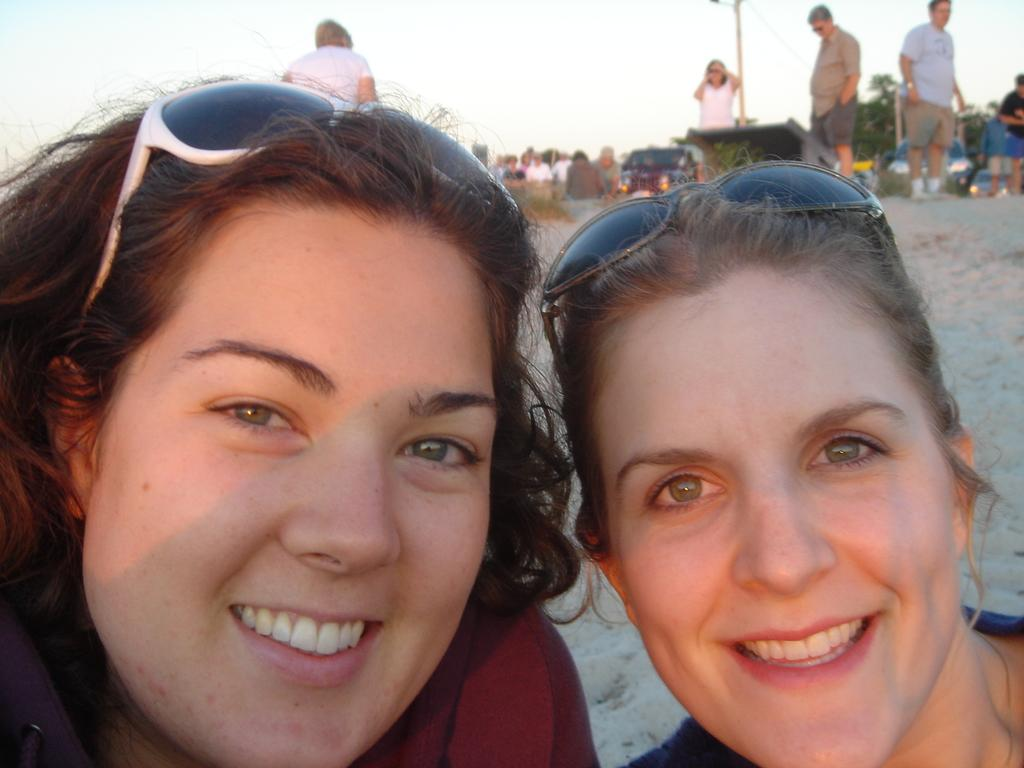How many persons are in the image? There are persons in the image, specifically two persons in the front. What are the two persons in the front wearing? The two persons in the front are wearing goggles. What is visible at the top of the image? The sky is visible at the top of the image. How many babies are crawling on the ground in the image? There are no babies present in the image. What type of fog can be seen in the image? There is no fog visible in the image; the sky is visible at the top of the image. 